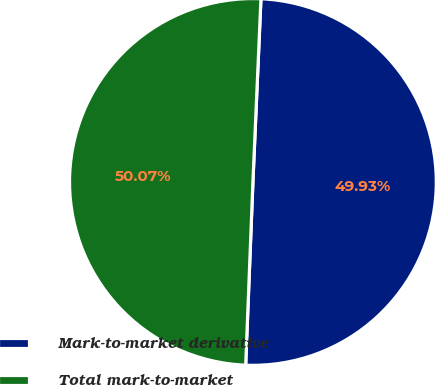Convert chart to OTSL. <chart><loc_0><loc_0><loc_500><loc_500><pie_chart><fcel>Mark-to-market derivative<fcel>Total mark-to-market<nl><fcel>49.93%<fcel>50.07%<nl></chart> 